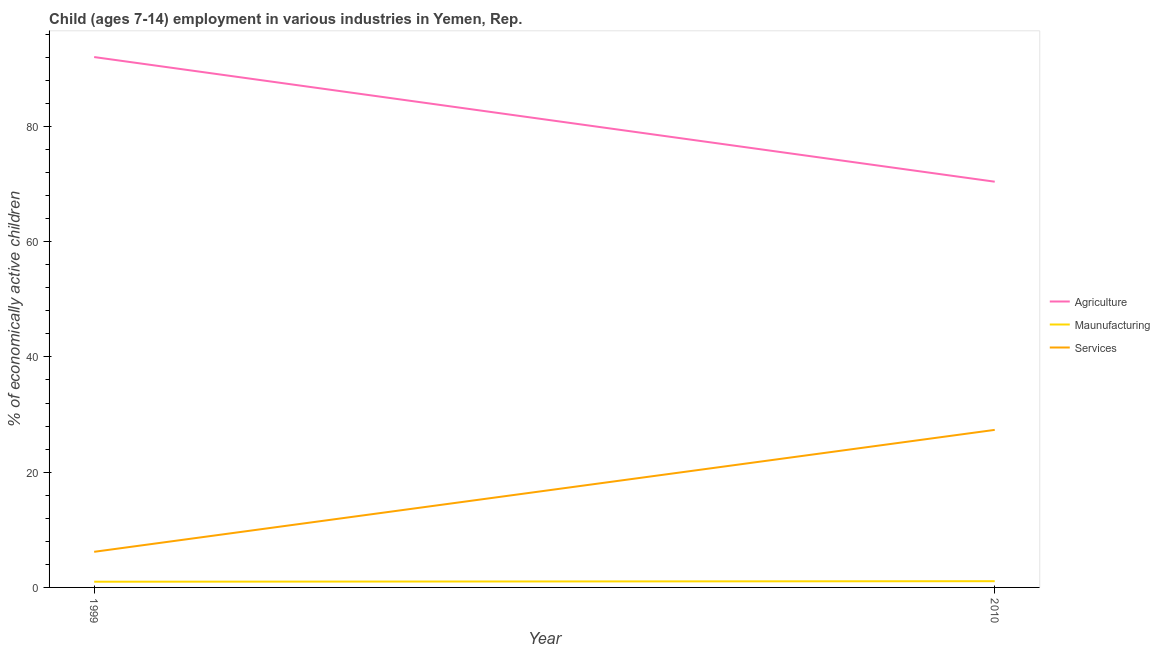Does the line corresponding to percentage of economically active children in manufacturing intersect with the line corresponding to percentage of economically active children in services?
Your response must be concise. No. What is the percentage of economically active children in manufacturing in 2010?
Ensure brevity in your answer.  1.08. Across all years, what is the maximum percentage of economically active children in agriculture?
Provide a succinct answer. 92.04. In which year was the percentage of economically active children in manufacturing minimum?
Provide a short and direct response. 1999. What is the total percentage of economically active children in agriculture in the graph?
Your answer should be very brief. 162.45. What is the difference between the percentage of economically active children in agriculture in 1999 and that in 2010?
Your answer should be very brief. 21.63. What is the average percentage of economically active children in services per year?
Offer a terse response. 16.76. In the year 1999, what is the difference between the percentage of economically active children in manufacturing and percentage of economically active children in services?
Give a very brief answer. -5.19. What is the ratio of the percentage of economically active children in services in 1999 to that in 2010?
Ensure brevity in your answer.  0.23. Does the percentage of economically active children in manufacturing monotonically increase over the years?
Your response must be concise. Yes. Is the percentage of economically active children in manufacturing strictly greater than the percentage of economically active children in agriculture over the years?
Offer a very short reply. No. Is the percentage of economically active children in services strictly less than the percentage of economically active children in agriculture over the years?
Give a very brief answer. Yes. What is the difference between two consecutive major ticks on the Y-axis?
Provide a short and direct response. 20. How are the legend labels stacked?
Make the answer very short. Vertical. What is the title of the graph?
Keep it short and to the point. Child (ages 7-14) employment in various industries in Yemen, Rep. Does "Neonatal" appear as one of the legend labels in the graph?
Ensure brevity in your answer.  No. What is the label or title of the X-axis?
Your response must be concise. Year. What is the label or title of the Y-axis?
Offer a very short reply. % of economically active children. What is the % of economically active children of Agriculture in 1999?
Provide a succinct answer. 92.04. What is the % of economically active children of Maunufacturing in 1999?
Your response must be concise. 0.99. What is the % of economically active children in Services in 1999?
Provide a succinct answer. 6.18. What is the % of economically active children in Agriculture in 2010?
Offer a very short reply. 70.41. What is the % of economically active children in Maunufacturing in 2010?
Your response must be concise. 1.08. What is the % of economically active children of Services in 2010?
Provide a short and direct response. 27.34. Across all years, what is the maximum % of economically active children in Agriculture?
Offer a very short reply. 92.04. Across all years, what is the maximum % of economically active children of Maunufacturing?
Ensure brevity in your answer.  1.08. Across all years, what is the maximum % of economically active children in Services?
Offer a terse response. 27.34. Across all years, what is the minimum % of economically active children in Agriculture?
Keep it short and to the point. 70.41. Across all years, what is the minimum % of economically active children of Services?
Keep it short and to the point. 6.18. What is the total % of economically active children of Agriculture in the graph?
Make the answer very short. 162.45. What is the total % of economically active children in Maunufacturing in the graph?
Your response must be concise. 2.07. What is the total % of economically active children of Services in the graph?
Offer a terse response. 33.52. What is the difference between the % of economically active children of Agriculture in 1999 and that in 2010?
Provide a short and direct response. 21.63. What is the difference between the % of economically active children in Maunufacturing in 1999 and that in 2010?
Your answer should be very brief. -0.09. What is the difference between the % of economically active children of Services in 1999 and that in 2010?
Make the answer very short. -21.16. What is the difference between the % of economically active children in Agriculture in 1999 and the % of economically active children in Maunufacturing in 2010?
Your answer should be compact. 90.96. What is the difference between the % of economically active children in Agriculture in 1999 and the % of economically active children in Services in 2010?
Give a very brief answer. 64.7. What is the difference between the % of economically active children of Maunufacturing in 1999 and the % of economically active children of Services in 2010?
Make the answer very short. -26.35. What is the average % of economically active children of Agriculture per year?
Your answer should be compact. 81.22. What is the average % of economically active children in Maunufacturing per year?
Offer a terse response. 1.03. What is the average % of economically active children in Services per year?
Keep it short and to the point. 16.76. In the year 1999, what is the difference between the % of economically active children in Agriculture and % of economically active children in Maunufacturing?
Offer a terse response. 91.05. In the year 1999, what is the difference between the % of economically active children of Agriculture and % of economically active children of Services?
Offer a very short reply. 85.86. In the year 1999, what is the difference between the % of economically active children of Maunufacturing and % of economically active children of Services?
Your answer should be very brief. -5.19. In the year 2010, what is the difference between the % of economically active children in Agriculture and % of economically active children in Maunufacturing?
Keep it short and to the point. 69.33. In the year 2010, what is the difference between the % of economically active children in Agriculture and % of economically active children in Services?
Your answer should be compact. 43.07. In the year 2010, what is the difference between the % of economically active children in Maunufacturing and % of economically active children in Services?
Make the answer very short. -26.26. What is the ratio of the % of economically active children in Agriculture in 1999 to that in 2010?
Provide a short and direct response. 1.31. What is the ratio of the % of economically active children of Maunufacturing in 1999 to that in 2010?
Ensure brevity in your answer.  0.92. What is the ratio of the % of economically active children in Services in 1999 to that in 2010?
Your response must be concise. 0.23. What is the difference between the highest and the second highest % of economically active children of Agriculture?
Make the answer very short. 21.63. What is the difference between the highest and the second highest % of economically active children of Maunufacturing?
Your response must be concise. 0.09. What is the difference between the highest and the second highest % of economically active children in Services?
Keep it short and to the point. 21.16. What is the difference between the highest and the lowest % of economically active children in Agriculture?
Provide a short and direct response. 21.63. What is the difference between the highest and the lowest % of economically active children of Maunufacturing?
Your answer should be compact. 0.09. What is the difference between the highest and the lowest % of economically active children of Services?
Give a very brief answer. 21.16. 